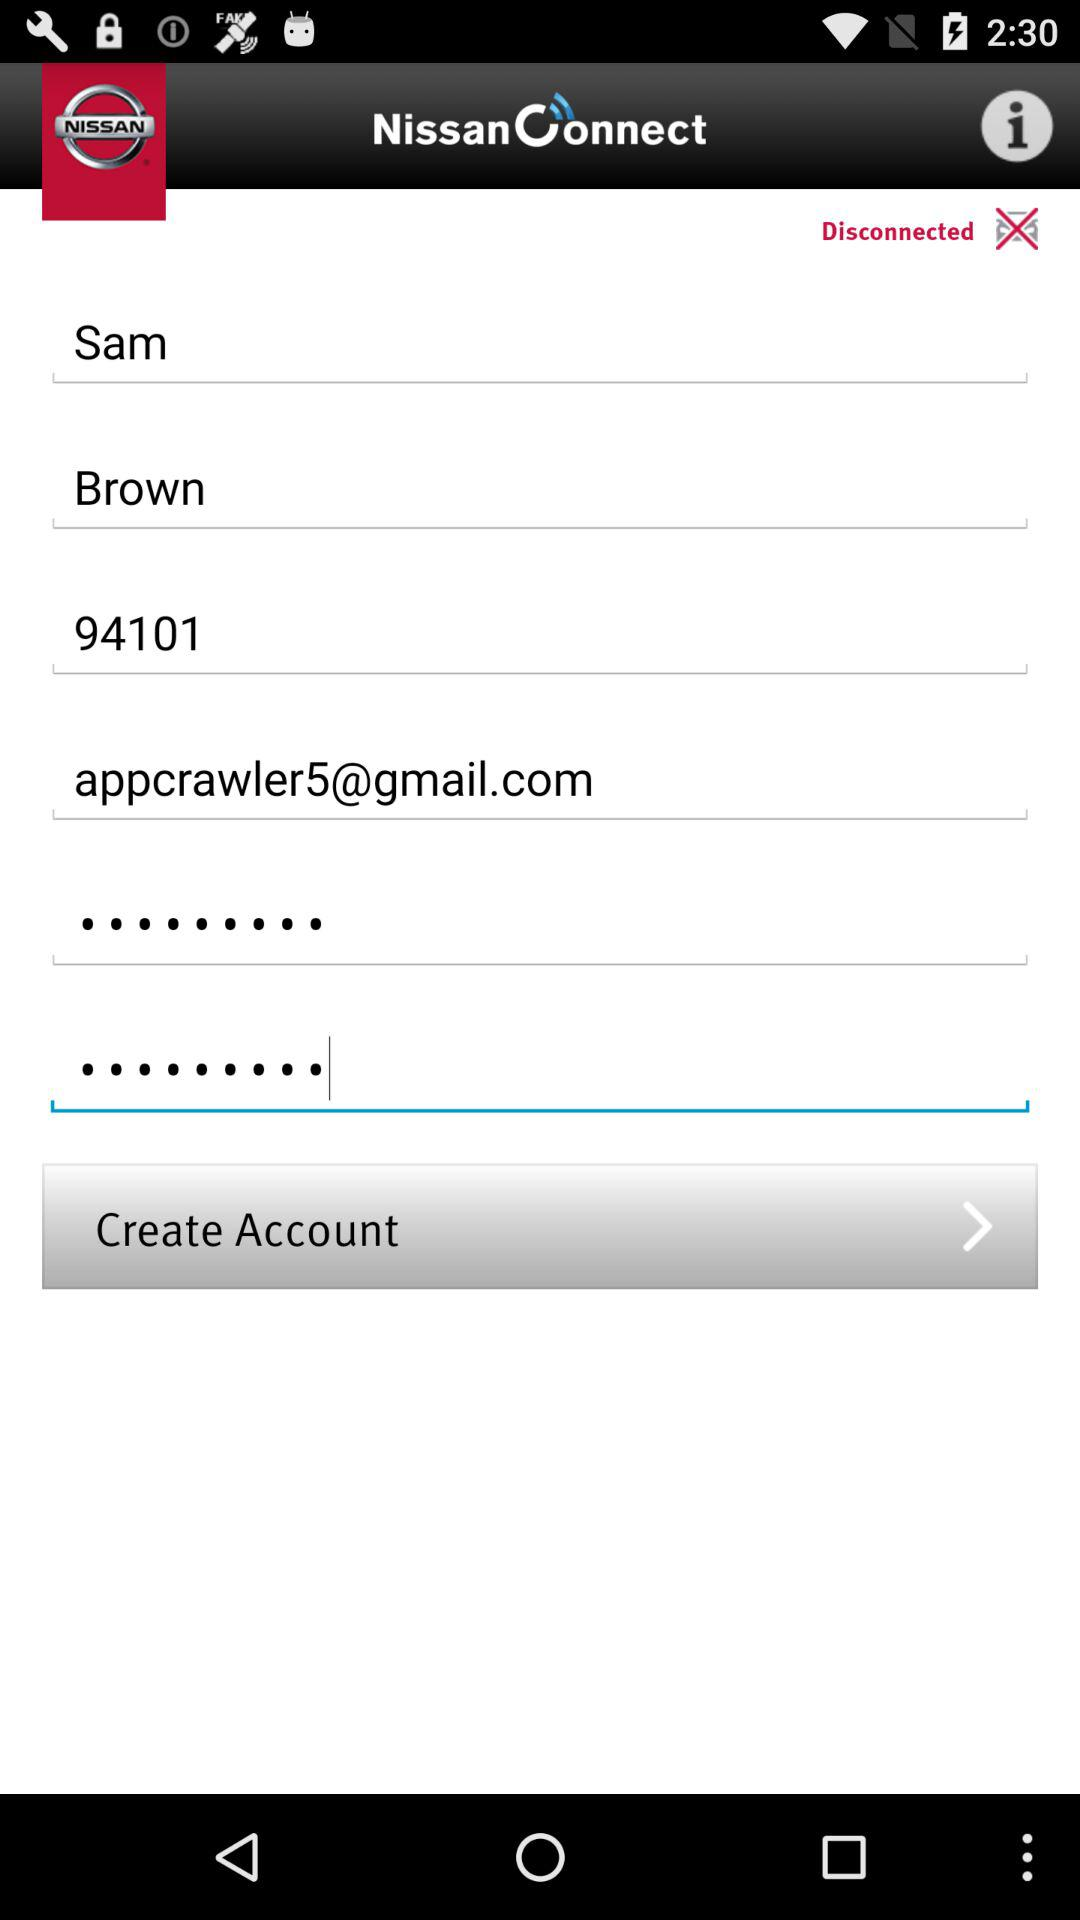What is the app name? The app name is "NissanConnect". 